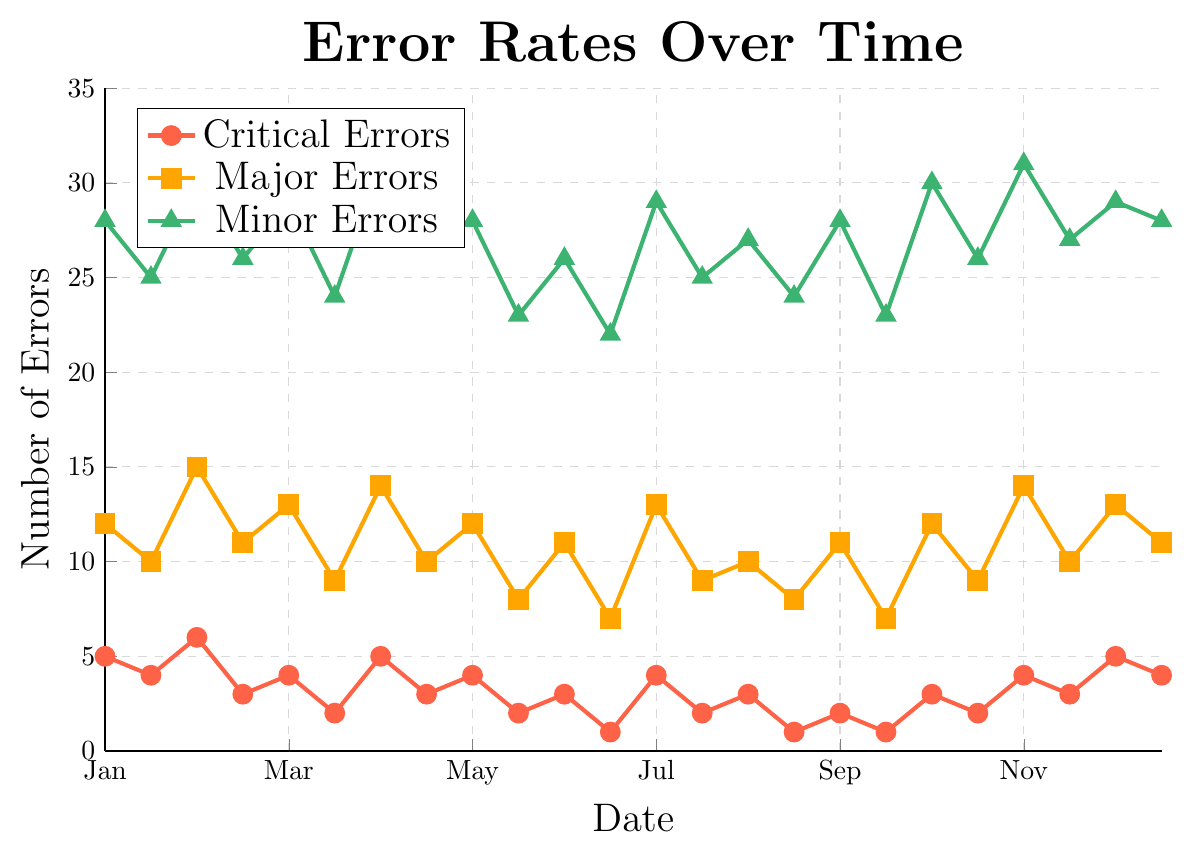What's the average number of critical errors reported in October? To find the average number of critical errors in October, sum up the values for October 1st and October 15th, and divide by 2. The values are 3 and 2, so the calculation is (3 + 2)/2 = 2.5
Answer: 2.5 How do the number of major errors in February compare to the number of critical errors in the same month? By referring to the chart, on February 1st and 15th, major errors are 15 and 11, while critical errors are 6 and 3. Total major errors are 15 + 11 = 26 and total critical errors are 6 + 3 = 9. Hence, major errors are greater than critical errors.
Answer: Major errors are greater What is the trend in minor errors from June to September? Observing the graph for June 1st, June 15th, July 1st, July 15th, August 1st, August 15th, September 1st, and September 15th, the values of minor errors are 26, 22, 29, 25, 27, 24, 28, and 23, respectively. The trend shows fluctuation but generally minor errors are decreasing by the end of September compared to the start of June.
Answer: Generally decreasing Which type of error experienced the highest number of occurrences in July? From the chart, observe the number of occurrences for each error type on July 1st and July 15th. Critical errors are 4 and 2, major errors are 13 and 9, and minor errors are 29 and 25. Minor errors have the highest occurrences in July.
Answer: Minor errors Are the minor errors more variable than the major errors throughout the year? Comparing the range (max-min) for minor errors (max 31, min 22) which is 31-22=9, and major errors (max 15, min 7) which is 15-7=8, it is evident that minor errors have a wider range, indicating more variability.
Answer: Yes What is the sum of all error types reported on December 1st? Sum the number of errors on December 1st: 5 (critical) + 13 (major) + 29 (minor) = 47
Answer: 47 In which month did critical errors drop to their lowest point? Referring to the chart, critical errors are at their lowest (1) on June 15th, August 15th, September 15th, and June 15th is the first occurrence of the drop.
Answer: June Do the critical errors ever surpass 6 in a single data point? By examining all critical error points in the chart, it is clear that the highest point is 6 and never surpasses it.
Answer: No What is the difference in the number of minor errors between the start of the year (January 1st) and mid-year (June 1st)? The number of minor errors on January 1st is 28 and on June 1st is 26. The difference is 28 - 26 = 2
Answer: 2 